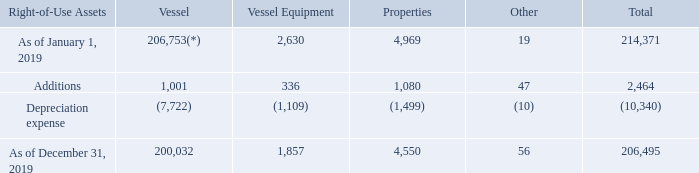GasLog Ltd. and its Subsidiaries
Notes to the consolidated financial statements (Continued)
For the years ended December 31, 2017, 2018 and 2019
(All amounts expressed in thousands of U.S. Dollars, except share and per share data)
7. Leases (Continued)
On February 24, 2016, GasLog’s subsidiary, GAS-twenty six Ltd., completed the sale and leaseback of the Methane Julia Louise with a subsidiary of Mitsui. Mitsui has the right to on-sell and lease back the vessel. The vessel was sold to Mitsui for a cash consideration of $217,000. GasLog leased back the vessel under a bareboat charter from Mitsui for a period of up to 20 years. GasLog has the option to repurchase the vessel on pre-agreed terms no earlier than the end of year ten and no later than the end of year 17 of the bareboat charter. The bareboat hire is fixed and GasLog had a holiday period for the first 210 days, which expired on September 21, 2016. This leaseback meets the definition of a finance lease under IAS 17 Leases.
The movements in right-of use assets are reported in the following table:
*The balance as of December 31, 2018 represented the vessel held under finance lease and was included in the financial statement line ‘‘Vessel held under finance lease’’, which was renamed to ‘‘Right-of-use assets’’ as of January 1, 2019.
How much was Methane Julia Louise sold for?
Answer scale should be: thousand. $217,000. Which company was the vessel sold to? Mitsui. What are the components of right-of use assets? Vessel, vessel equipment, properties, other. Which month was the vessel equipment higher? 2,630 > 1,857
Answer: january. What was the change in properties from start to end 2019?
Answer scale should be: thousand. 4,969 - 4,550 
Answer: 419. What was the percentage change in total right-of use assets  from start to end 2019?
Answer scale should be: percent. (206,495 - 214,371)/214,371 
Answer: -3.67. 